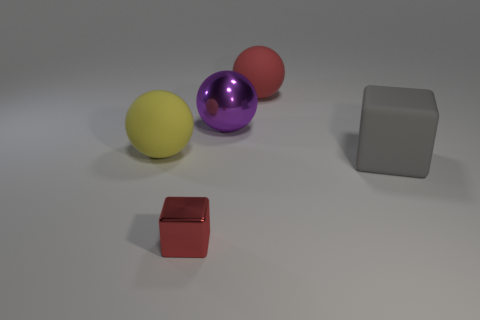Can you describe the relative positions of the objects? Certainly! In the image, there are two balls and two blocks. The purple and red balls are closer to each other, with the purple one slightly farther to the left. The yellow ball is to the left and forward of the purple ball. The metallic block is far to the right and a bit behind the red block, which is smaller and in the foreground. 